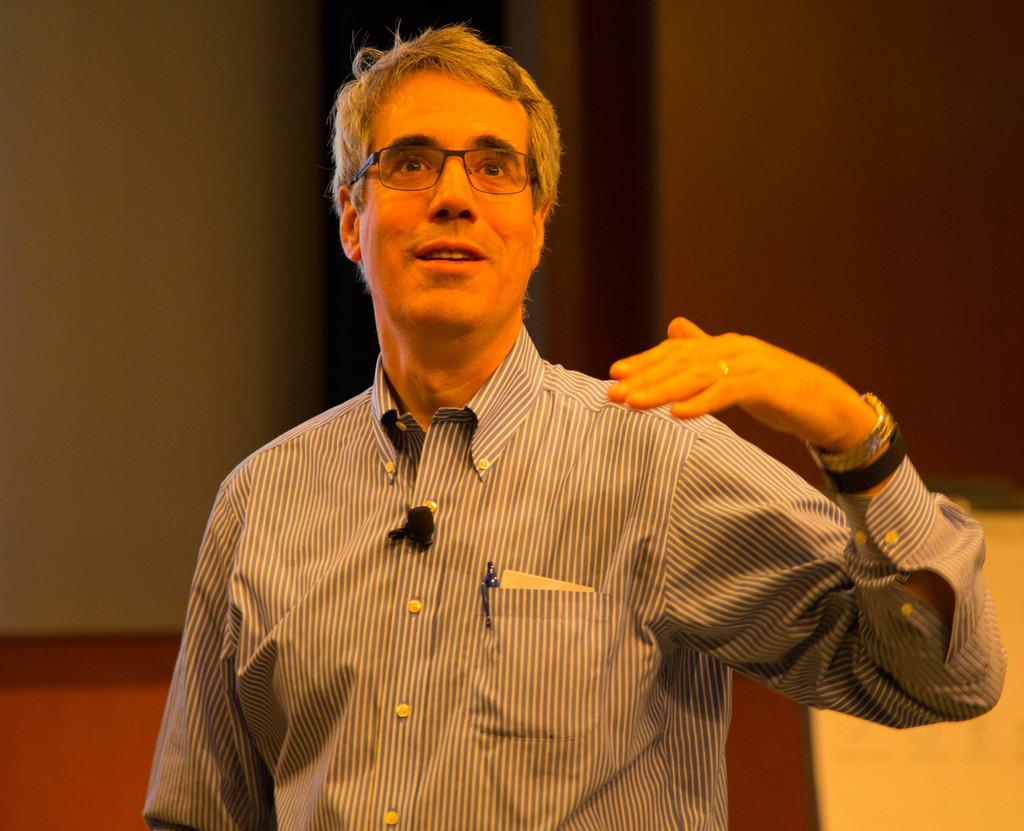What is the main subject of the image? There is a person in the image. Can you describe the person's appearance? The person is wearing clothes and spectacles. What can be observed about the background of the image? The background of the image is blurred. What type of curtain is hanging in the background of the image? There is no curtain present in the image; the background is blurred. How many dolls are sitting on the person's lap in the image? There are no dolls present in the image; it features a person wearing clothes and spectacles. 